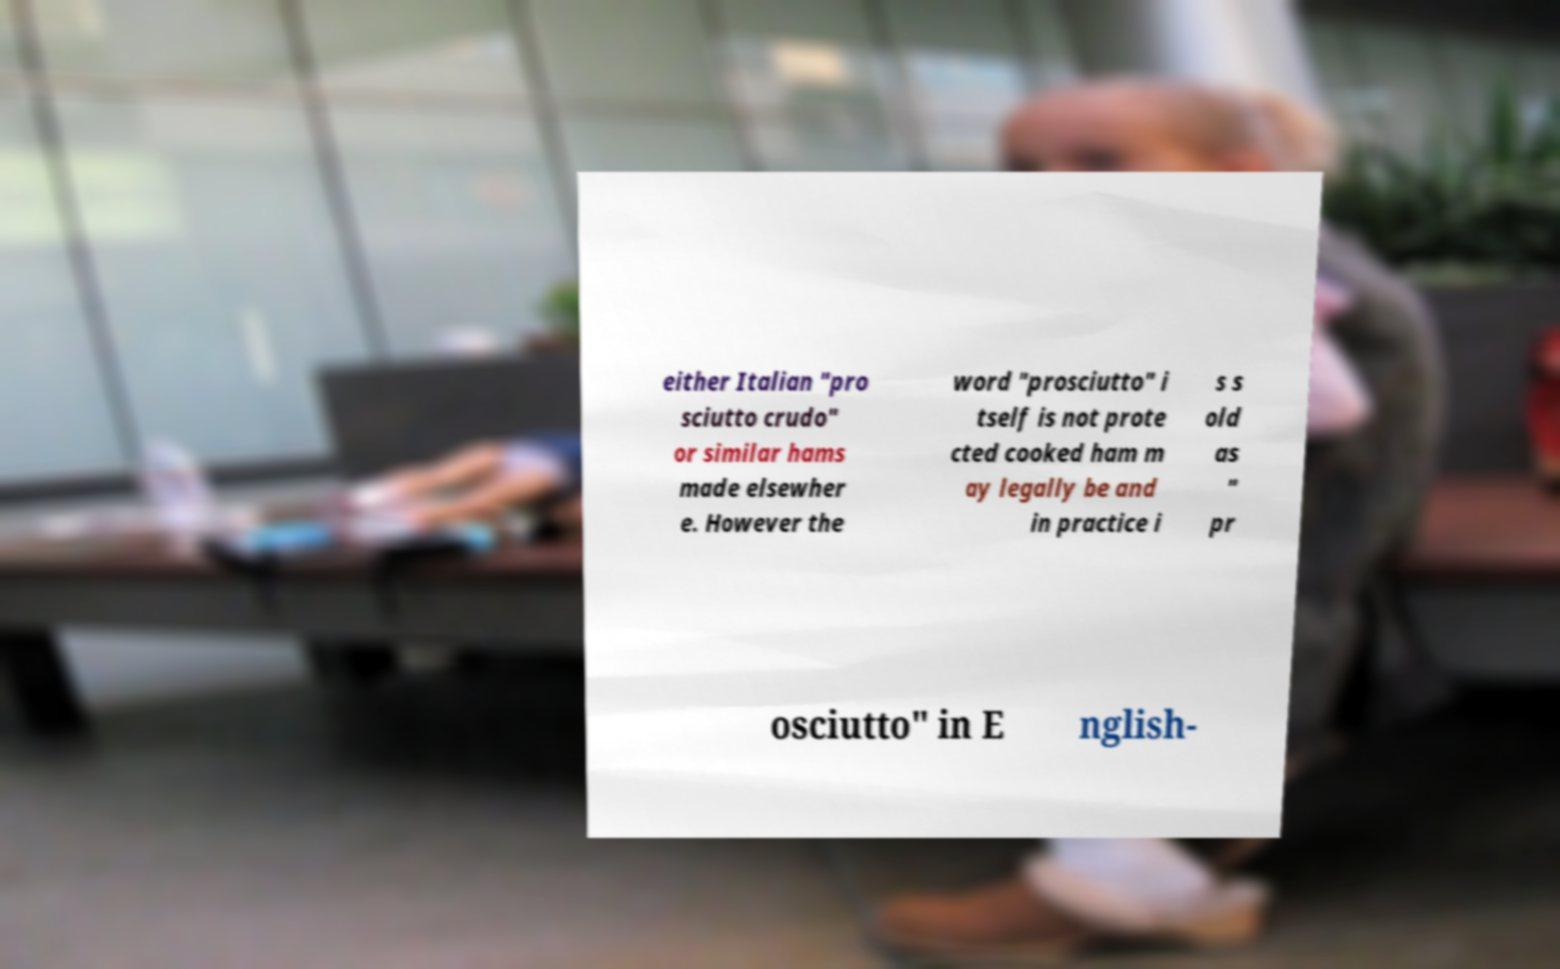For documentation purposes, I need the text within this image transcribed. Could you provide that? either Italian "pro sciutto crudo" or similar hams made elsewher e. However the word "prosciutto" i tself is not prote cted cooked ham m ay legally be and in practice i s s old as " pr osciutto" in E nglish- 